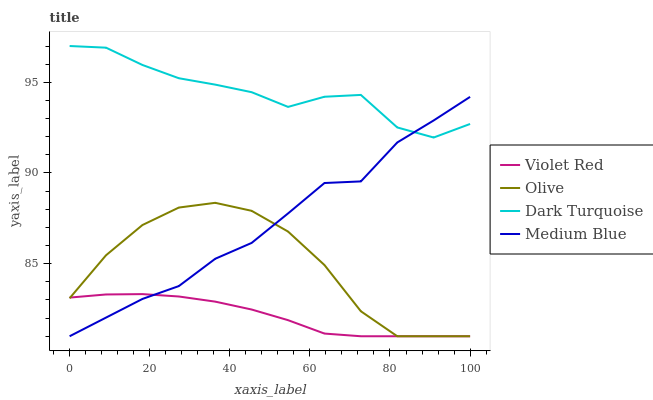Does Violet Red have the minimum area under the curve?
Answer yes or no. Yes. Does Dark Turquoise have the maximum area under the curve?
Answer yes or no. Yes. Does Dark Turquoise have the minimum area under the curve?
Answer yes or no. No. Does Violet Red have the maximum area under the curve?
Answer yes or no. No. Is Violet Red the smoothest?
Answer yes or no. Yes. Is Dark Turquoise the roughest?
Answer yes or no. Yes. Is Dark Turquoise the smoothest?
Answer yes or no. No. Is Violet Red the roughest?
Answer yes or no. No. Does Olive have the lowest value?
Answer yes or no. Yes. Does Dark Turquoise have the lowest value?
Answer yes or no. No. Does Dark Turquoise have the highest value?
Answer yes or no. Yes. Does Violet Red have the highest value?
Answer yes or no. No. Is Violet Red less than Dark Turquoise?
Answer yes or no. Yes. Is Dark Turquoise greater than Olive?
Answer yes or no. Yes. Does Medium Blue intersect Dark Turquoise?
Answer yes or no. Yes. Is Medium Blue less than Dark Turquoise?
Answer yes or no. No. Is Medium Blue greater than Dark Turquoise?
Answer yes or no. No. Does Violet Red intersect Dark Turquoise?
Answer yes or no. No. 